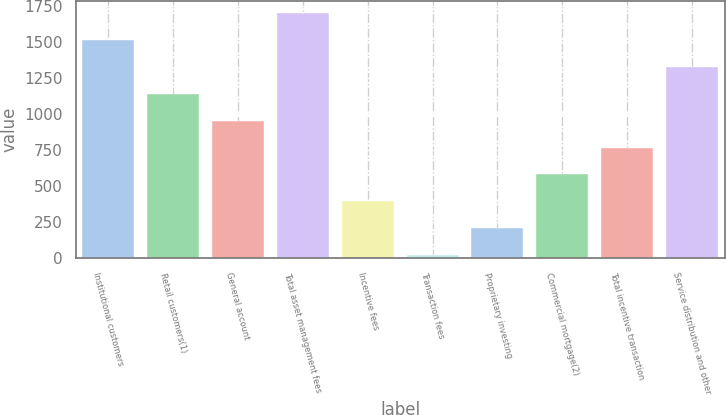<chart> <loc_0><loc_0><loc_500><loc_500><bar_chart><fcel>Institutional customers<fcel>Retail customers(1)<fcel>General account<fcel>Total asset management fees<fcel>Incentive fees<fcel>Transaction fees<fcel>Proprietary investing<fcel>Commercial mortgage(2)<fcel>Total incentive transaction<fcel>Service distribution and other<nl><fcel>1515<fcel>1142<fcel>955.5<fcel>1701.5<fcel>396<fcel>23<fcel>209.5<fcel>582.5<fcel>769<fcel>1328.5<nl></chart> 